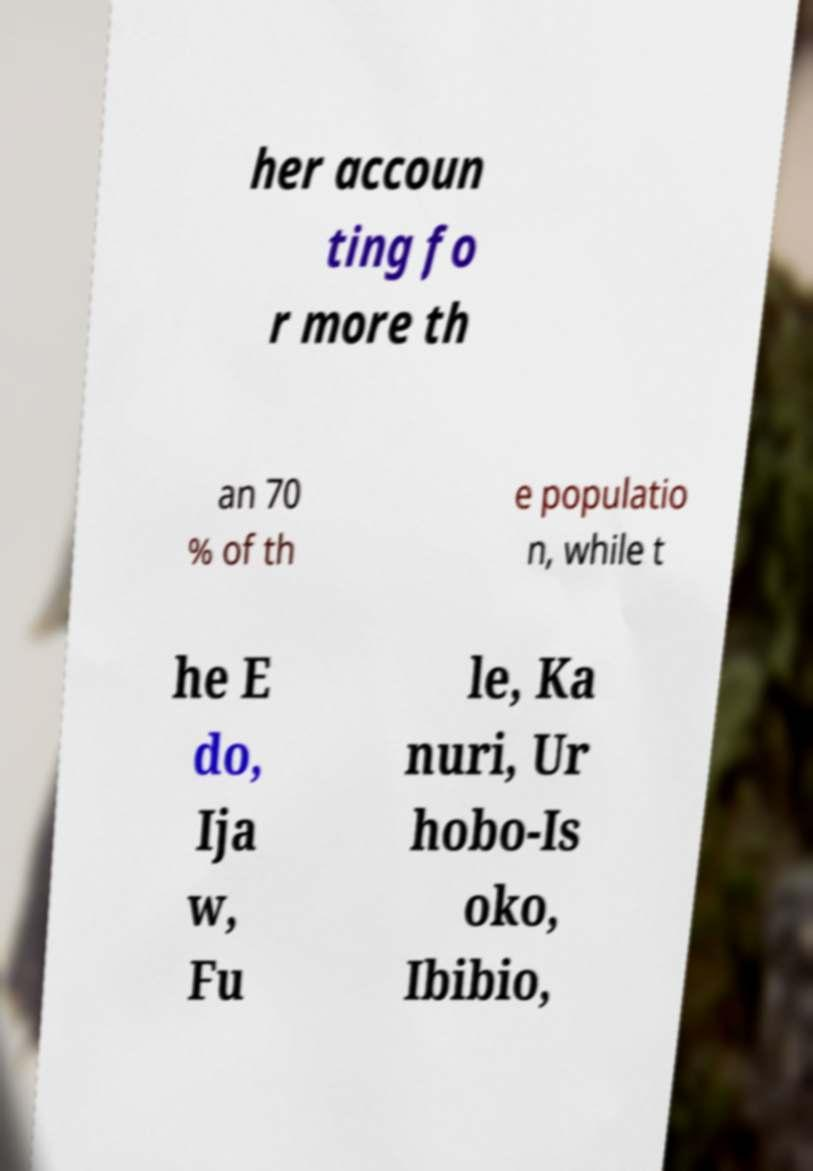What messages or text are displayed in this image? I need them in a readable, typed format. her accoun ting fo r more th an 70 % of th e populatio n, while t he E do, Ija w, Fu le, Ka nuri, Ur hobo-Is oko, Ibibio, 